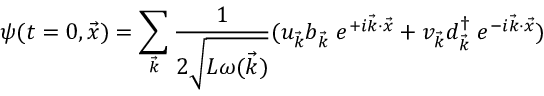<formula> <loc_0><loc_0><loc_500><loc_500>\psi ( t = 0 , \vec { x } ) = \sum _ { \vec { k } } { \frac { 1 } { 2 \sqrt { L \omega ( \vec { k } ) } } } ( u _ { \vec { k } } b _ { \vec { k } } \, e ^ { + i \vec { k } \cdot \vec { x } } + v _ { \vec { k } } d _ { \vec { k } } ^ { \dag } \, e ^ { - i \vec { k } \cdot \vec { x } } )</formula> 